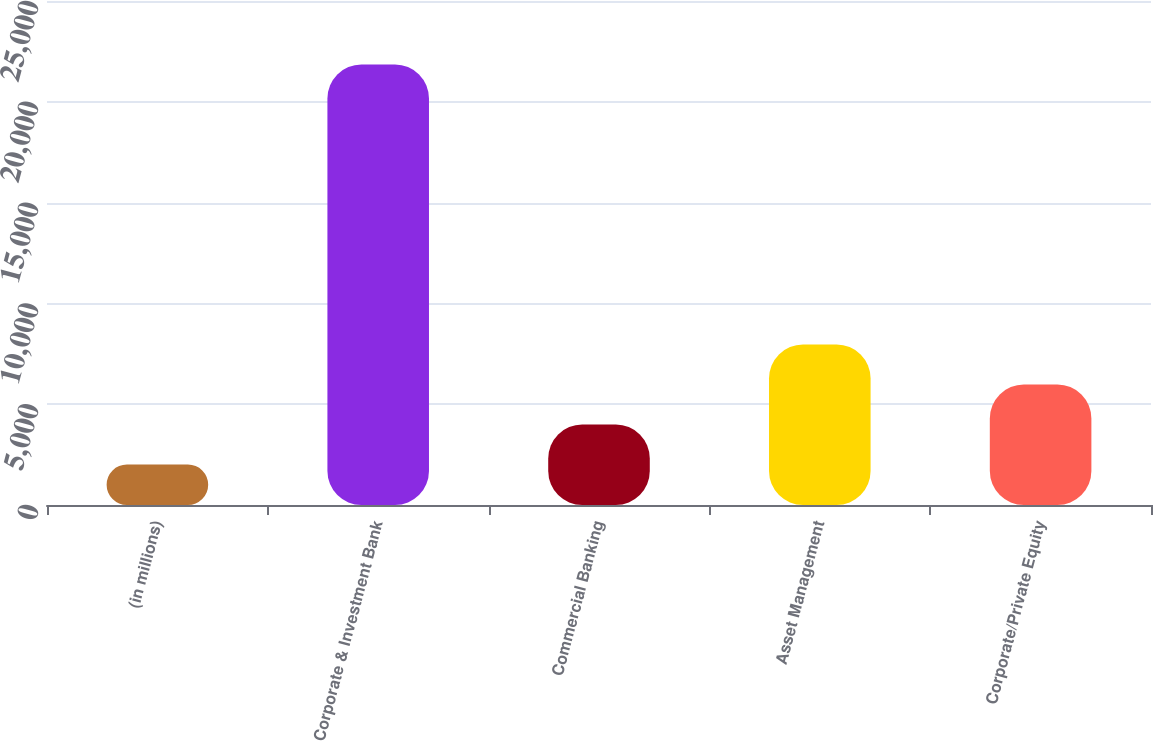Convert chart to OTSL. <chart><loc_0><loc_0><loc_500><loc_500><bar_chart><fcel>(in millions)<fcel>Corporate & Investment Bank<fcel>Commercial Banking<fcel>Asset Management<fcel>Corporate/Private Equity<nl><fcel>2012<fcel>21850<fcel>3995.8<fcel>7963.4<fcel>5979.6<nl></chart> 